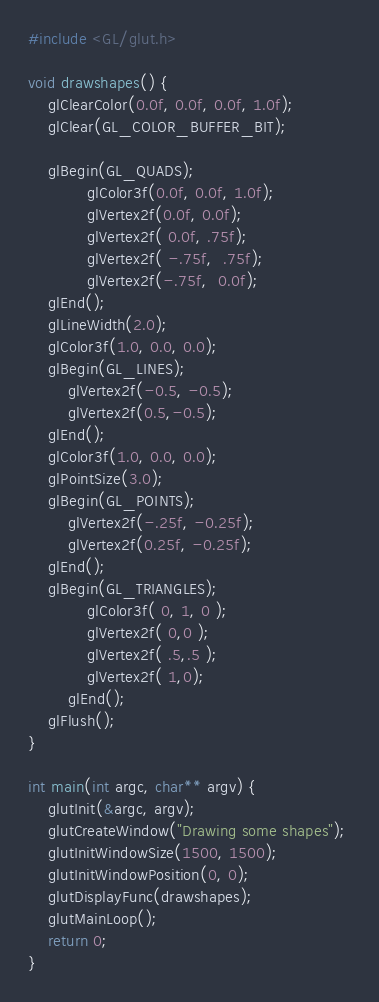<code> <loc_0><loc_0><loc_500><loc_500><_C_>#include <GL/glut.h> 

void drawshapes() {
	glClearColor(0.0f, 0.0f, 0.0f, 1.0f); 
   	glClear(GL_COLOR_BUFFER_BIT);        

   	glBegin(GL_QUADS);             
      		glColor3f(0.0f, 0.0f, 1.0f);
     		glVertex2f(0.0f, 0.0f);    
      		glVertex2f( 0.0f, .75f);
      		glVertex2f( -.75f,  .75f);
      		glVertex2f(-.75f,  0.0f);
   	glEnd();
	glLineWidth(2.0);
	glColor3f(1.0, 0.0, 0.0);
	glBegin(GL_LINES);
		glVertex2f(-0.5, -0.5);
		glVertex2f(0.5,-0.5);
	glEnd();
	glColor3f(1.0, 0.0, 0.0);
	glPointSize(3.0);
	glBegin(GL_POINTS);
  		glVertex2f(-.25f, -0.25f); 
  		glVertex2f(0.25f, -0.25f); 
	glEnd(); 
   	glBegin(GL_TRIANGLES);
    		glColor3f( 0, 1, 0 );
    		glVertex2f( 0,0 );
    		glVertex2f( .5,.5 );
    		glVertex2f( 1,0);
    	glEnd(); 
   	glFlush();  
}
 
int main(int argc, char** argv) {
	glutInit(&argc, argv);                 
   	glutCreateWindow("Drawing some shapes"); 
   	glutInitWindowSize(1500, 1500);   
   	glutInitWindowPosition(0, 0); 
   	glutDisplayFunc(drawshapes); 
   	glutMainLoop();          
   	return 0;
}</code> 